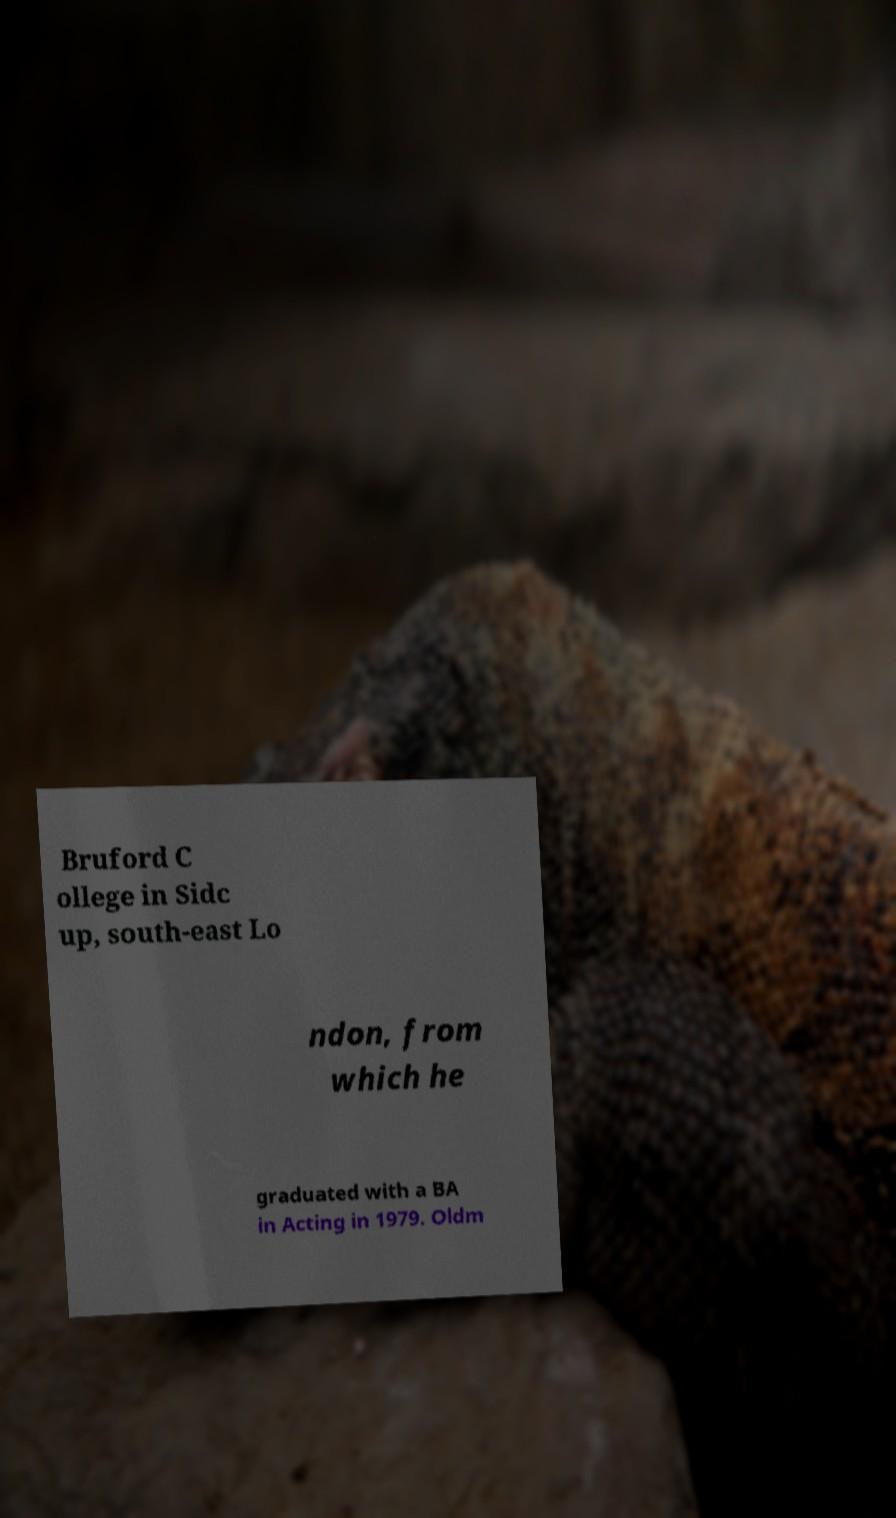For documentation purposes, I need the text within this image transcribed. Could you provide that? Bruford C ollege in Sidc up, south-east Lo ndon, from which he graduated with a BA in Acting in 1979. Oldm 